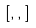<formula> <loc_0><loc_0><loc_500><loc_500>[ , , ]</formula> 